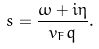<formula> <loc_0><loc_0><loc_500><loc_500>s = \frac { \omega + i \eta } { v _ { F } q } .</formula> 